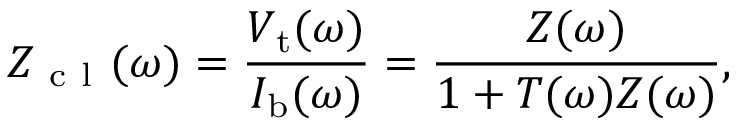Convert formula to latex. <formula><loc_0><loc_0><loc_500><loc_500>Z _ { c l } ( \omega ) = \frac { V _ { t } ( \omega ) } { I _ { b } ( \omega ) } = \frac { Z ( \omega ) } { 1 + T ( \omega ) Z ( \omega ) } ,</formula> 